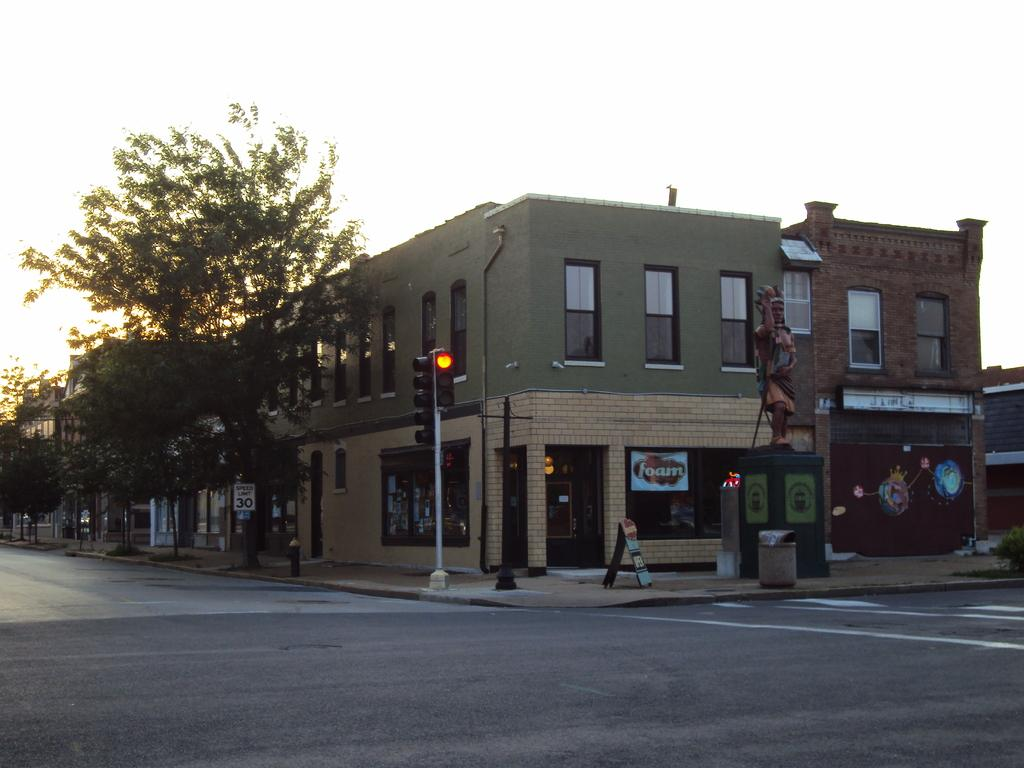What type of structure can be seen in the background of the image? There is a building in the background of the image. What is the purpose of the object that is emitting light in the image? There is a street light in the image, which provides illumination for the area. What type of vegetation is present in the image? There are trees in the image. What surface can be seen at the bottom of the image? There is a road at the bottom of the image. What type of bike is being used for learning in the image? There is no bike present in the image, and therefore no learning activity involving a bike can be observed. 